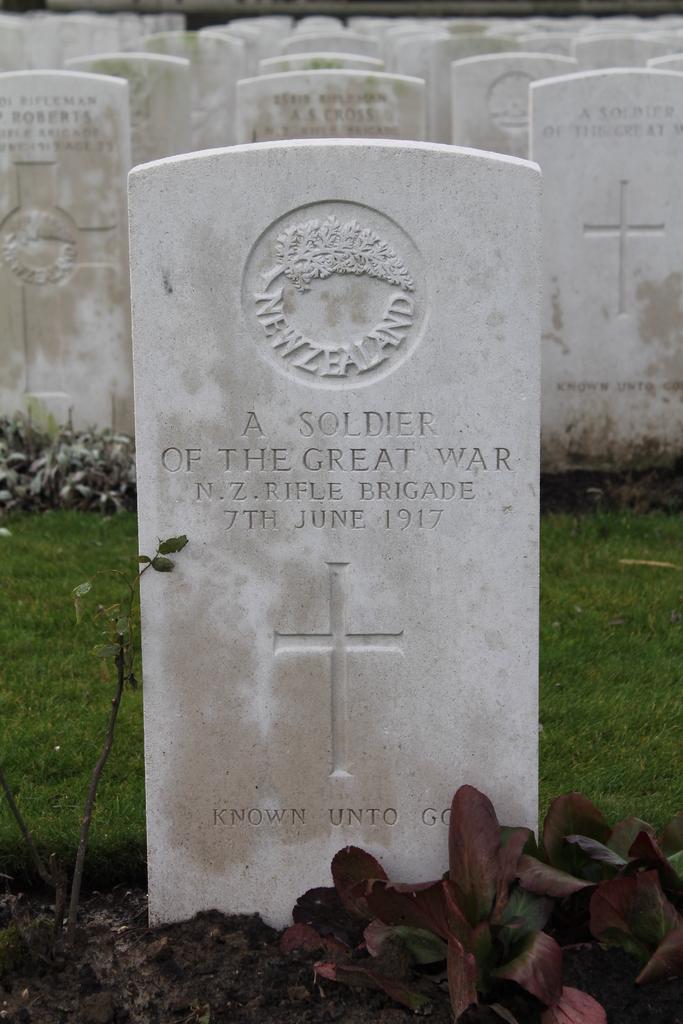Can you describe this image briefly? In this picture I can see tombstones, grass and there are plants. 